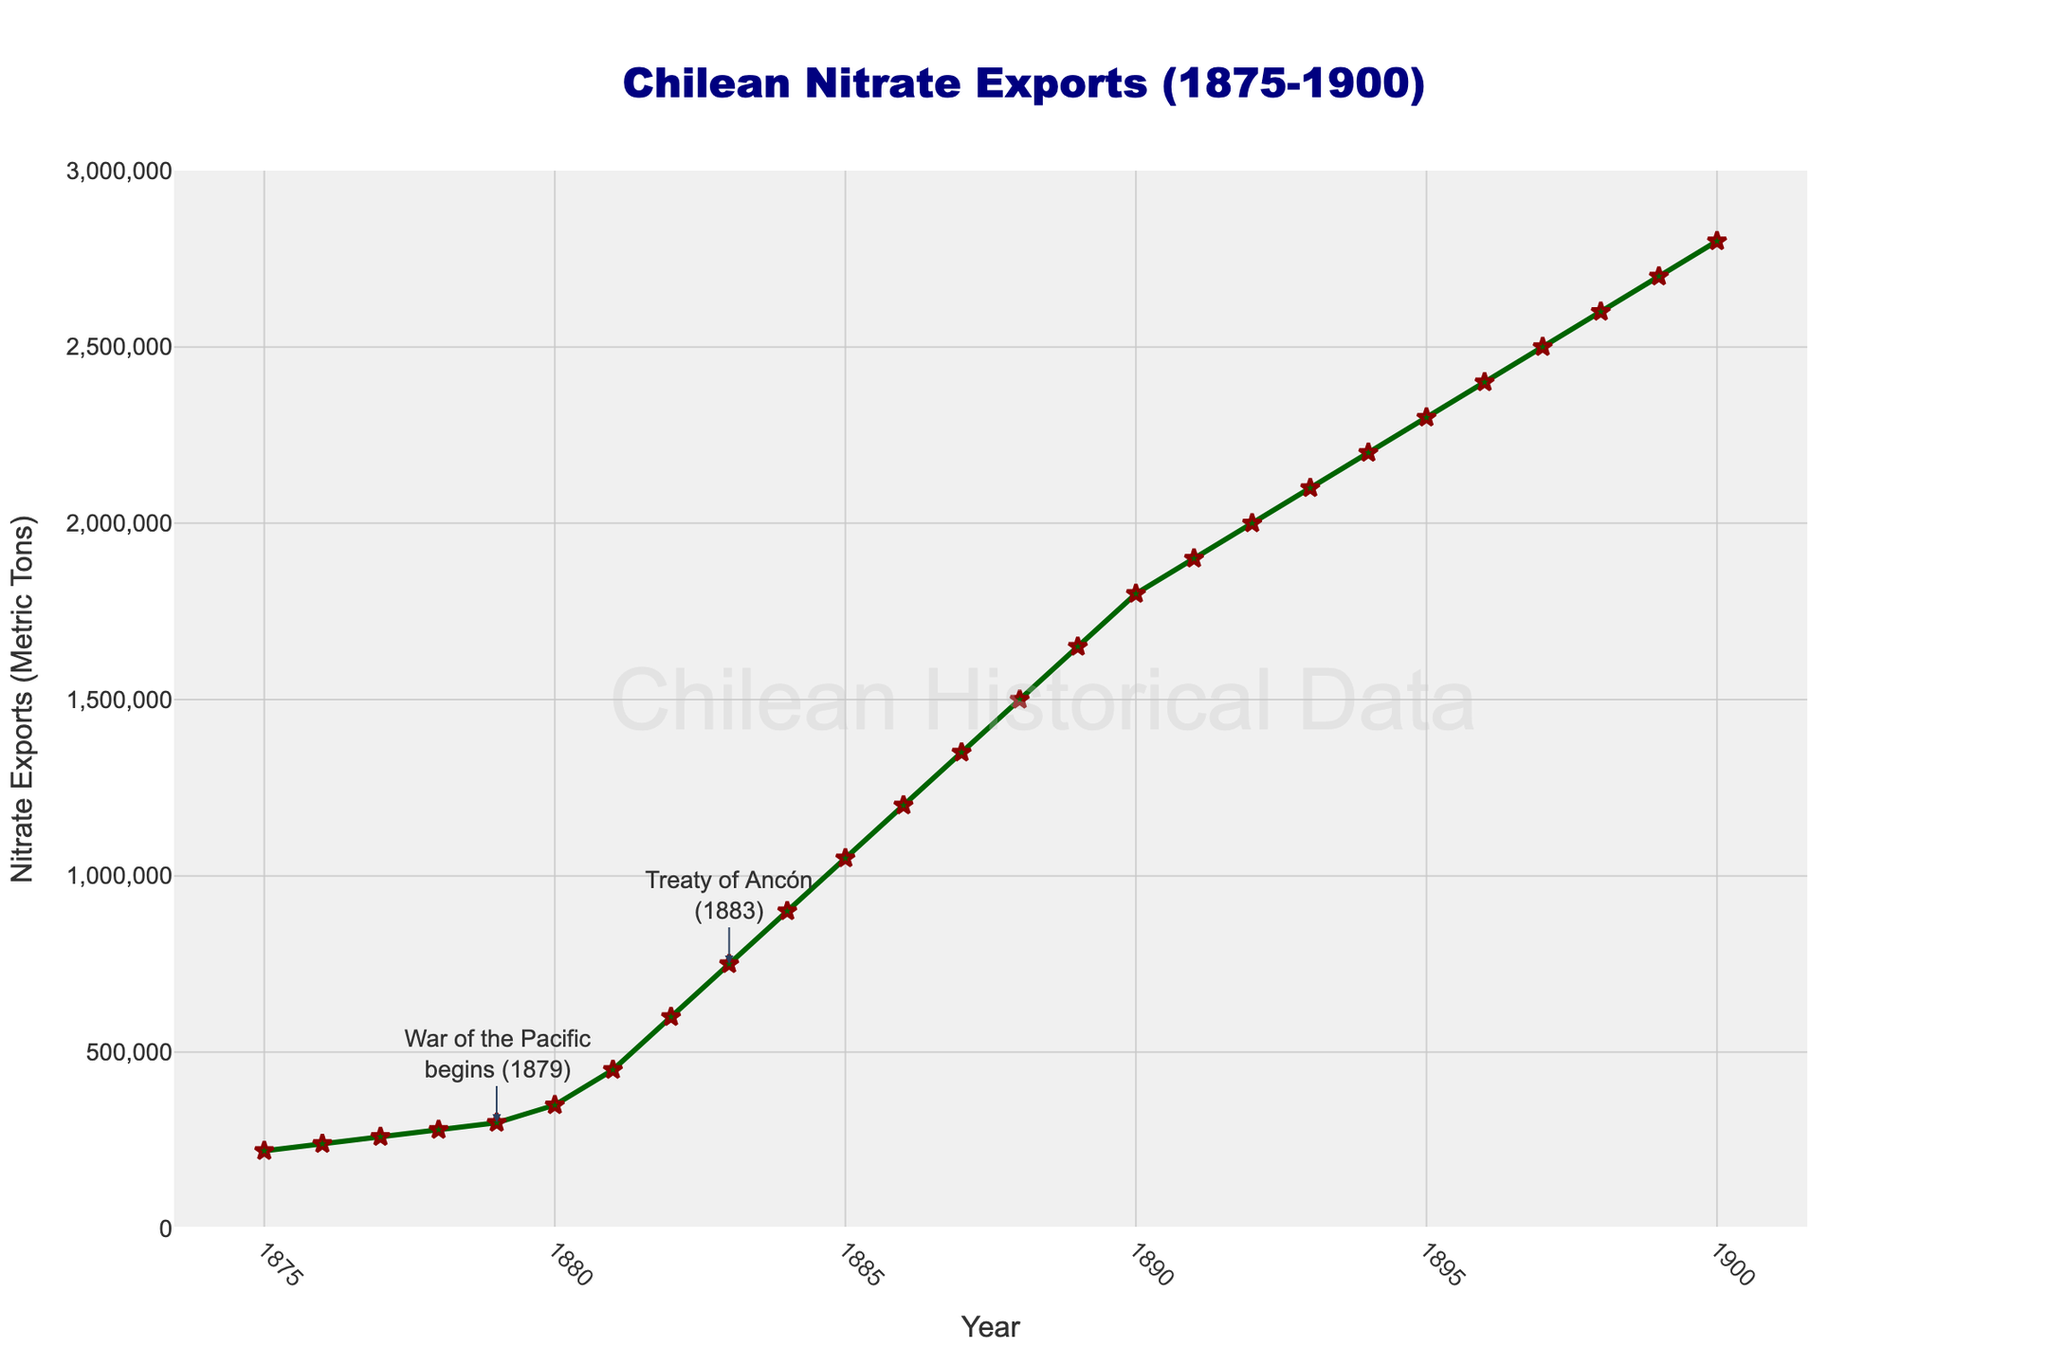What year did Chilean nitrate exports first reach 1,000,000 metric tons? By observing the plot, we need to find the year where the nitrate exports line first crosses the 1,000,000 metric tons mark. From the figure, it is seen that the exports reach 1,000,000 metric tons in 1884.
Answer: 1884 How much did nitrate exports increase from 1878 to 1884? Look at the nitrate export values for the years 1878 and 1884. The value in 1878 is 280,000 metric tons and in 1884 is 900,000 metric tons. Subtract the value for 1878 from 1884: 900,000 - 280,000 = 620,000 metric tons.
Answer: 620,000 metric tons Which year had the highest nitrate exports, 1880 or 1890? Compare the nitrate export values for the years 1880 and 1890. The value in 1880 is 350,000 metric tons and in 1890 is 1,800,000 metric tons. Therefore, 1890 has the higher value.
Answer: 1890 By what percentage did nitrate exports grow from 1881 to 1883? First, find the exports for the years 1881 and 1883: 1881 has 450,000 metric tons and 1883 has 750,000 metric tons. Calculate the growth: (750,000 - 450,000) / 450,000 * 100% = 66.67%.
Answer: 66.67% What marked event is highlighted in 1883 on the plot? Look at the annotation on the plot for 1883. The figure highlights the "Treaty of Ancón (1883).”
Answer: Treaty of Ancón (1883) Was there a significant jump in nitrate exports during the War of the Pacific (1879-1883)? Observe the nitrate export values from 1879 to 1883. There is a significant increase: from 300,000 metric tons in 1879 to 750,000 metric tons in 1883.
Answer: Yes Calculate the approximate annual average increase in nitrate exports from 1885 to 1890. First, find the nitrate exports values for 1885 and 1890: 1,050,000 metric tons and 1,800,000 metric tons respectively. The total increase over 5 years is 1,800,000 - 1,050,000 = 750,000 metric tons. The annual average increase is 750,000 / 5 = 150,000 metric tons.
Answer: 150,000 metric tons Which color and shape are used to mark the nitrate export data points in the plot? Observe the plot's visual attributes. The data points are marked with a green line and star-shaped markers with a red outline.
Answer: green line, star-shaped markers with red outline How did the nitrate exports change immediately following the War of the Pacific's beginning? Look at the plot for the years around 1879. Nitrate exports were 300,000 metric tons in 1879 and increased to 450,000 metric tons in 1881, indicating a significant rise.
Answer: Significant rise How many times did the export amount increase from 1875 to 1900? Compare the values: 220,000 metric tons in 1875 and 2,800,000 metric tons in 1900. Calculate the ratio: 2,800,000 / 220,000 ≈ 12.73, so the amount increased approximately 12.73 times.
Answer: 12.73 times 